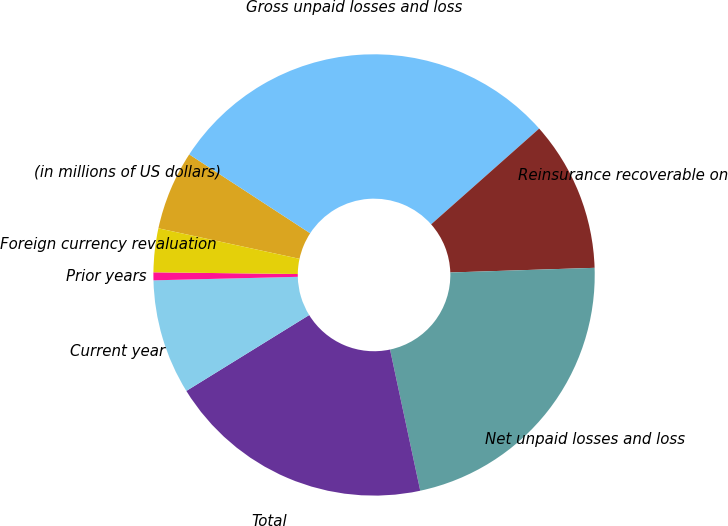Convert chart to OTSL. <chart><loc_0><loc_0><loc_500><loc_500><pie_chart><fcel>(in millions of US dollars)<fcel>Gross unpaid losses and loss<fcel>Reinsurance recoverable on<fcel>Net unpaid losses and loss<fcel>Total<fcel>Current year<fcel>Prior years<fcel>Foreign currency revaluation<nl><fcel>5.81%<fcel>29.26%<fcel>11.03%<fcel>22.16%<fcel>19.55%<fcel>8.42%<fcel>0.58%<fcel>3.2%<nl></chart> 